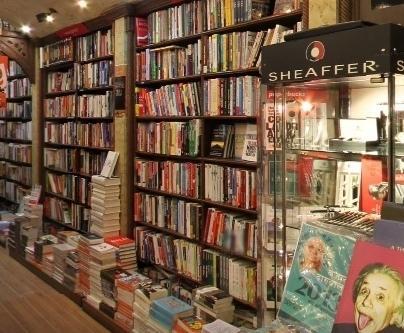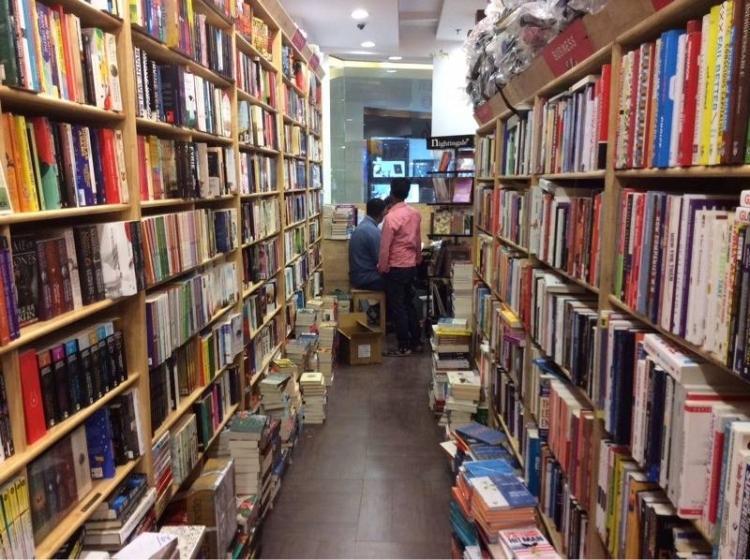The first image is the image on the left, the second image is the image on the right. For the images shown, is this caption "At least one person is standing in the aisle of a bookstore." true? Answer yes or no. Yes. The first image is the image on the left, the second image is the image on the right. For the images displayed, is the sentence "A back-turned person wearing something pinkish stands in the aisle at the very center of the bookstore, with tall shelves surrounding them." factually correct? Answer yes or no. Yes. 